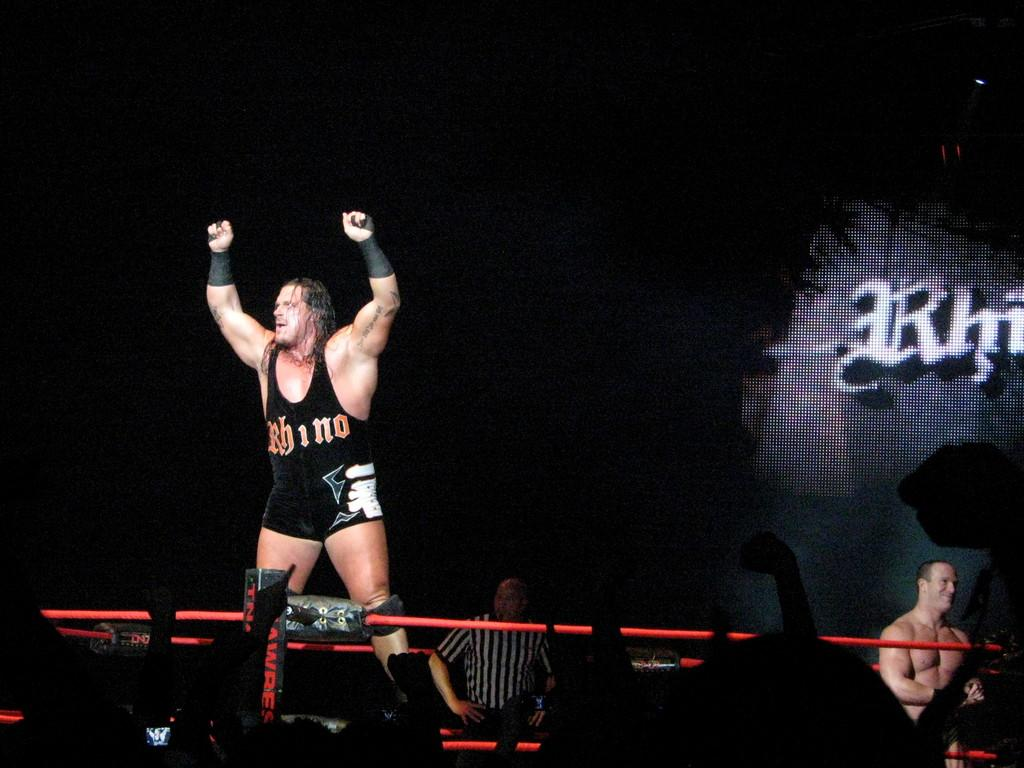Provide a one-sentence caption for the provided image. A wrestler with Rhino on his uniform stand with his arms raised in the air. 